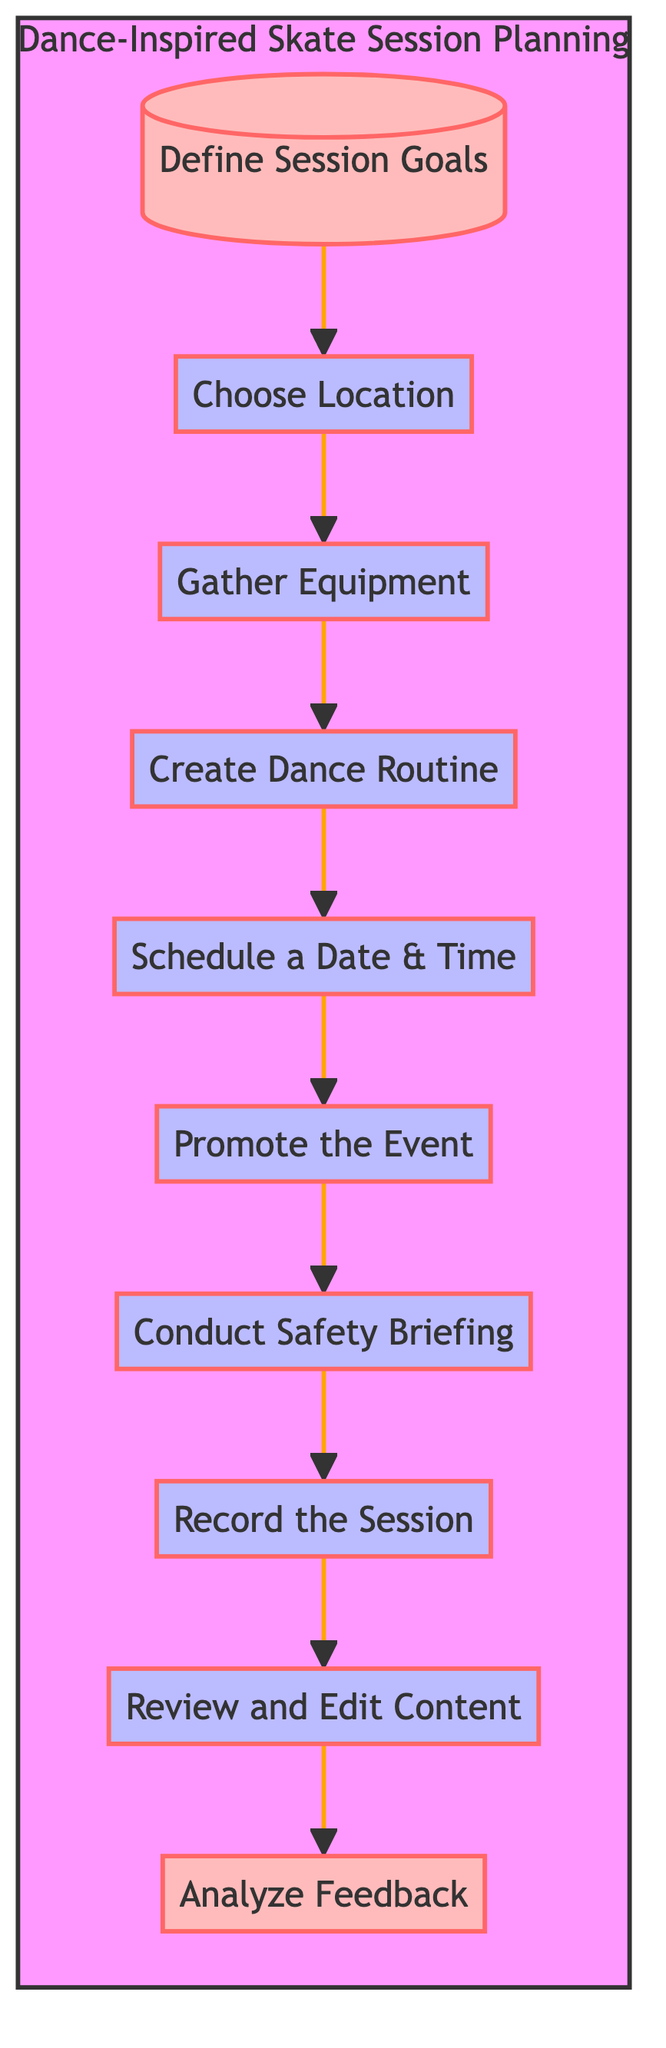What is the first step in planning a dance-inspired skate session? The diagram shows that the first node is "Define Session Goals," which is the initial action to identify what to achieve in the session.
Answer: Define Session Goals How many nodes are in the flowchart? There are a total of ten nodes listed in the diagram, representing different steps in planning the session.
Answer: 10 Which node comes after "Gather Equipment"? After "Gather Equipment," the next node in the flowchart is "Create Dance Routine," indicating the progression to develop a choreographed sequence.
Answer: Create Dance Routine What is the purpose of "Conduct Safety Briefing"? This node emphasizes ensuring that all participants are aware of safety practices before starting the session, focusing on participant safety.
Answer: Ensure safety practices Which steps need to be completed before recording the session? Prior to "Record the Session," the preceding steps include "Define Session Goals," "Choose Location," "Gather Equipment," "Create Dance Routine," "Schedule a Date & Time," "Promote the Event," and "Conduct Safety Briefing." Each step prepares for the recording.
Answer: All previous steps What is the last activity in the diagram? The last node represents "Analyze Feedback," which is the conclusive step where participant feedback is collected for improvements in future sessions.
Answer: Analyze Feedback 